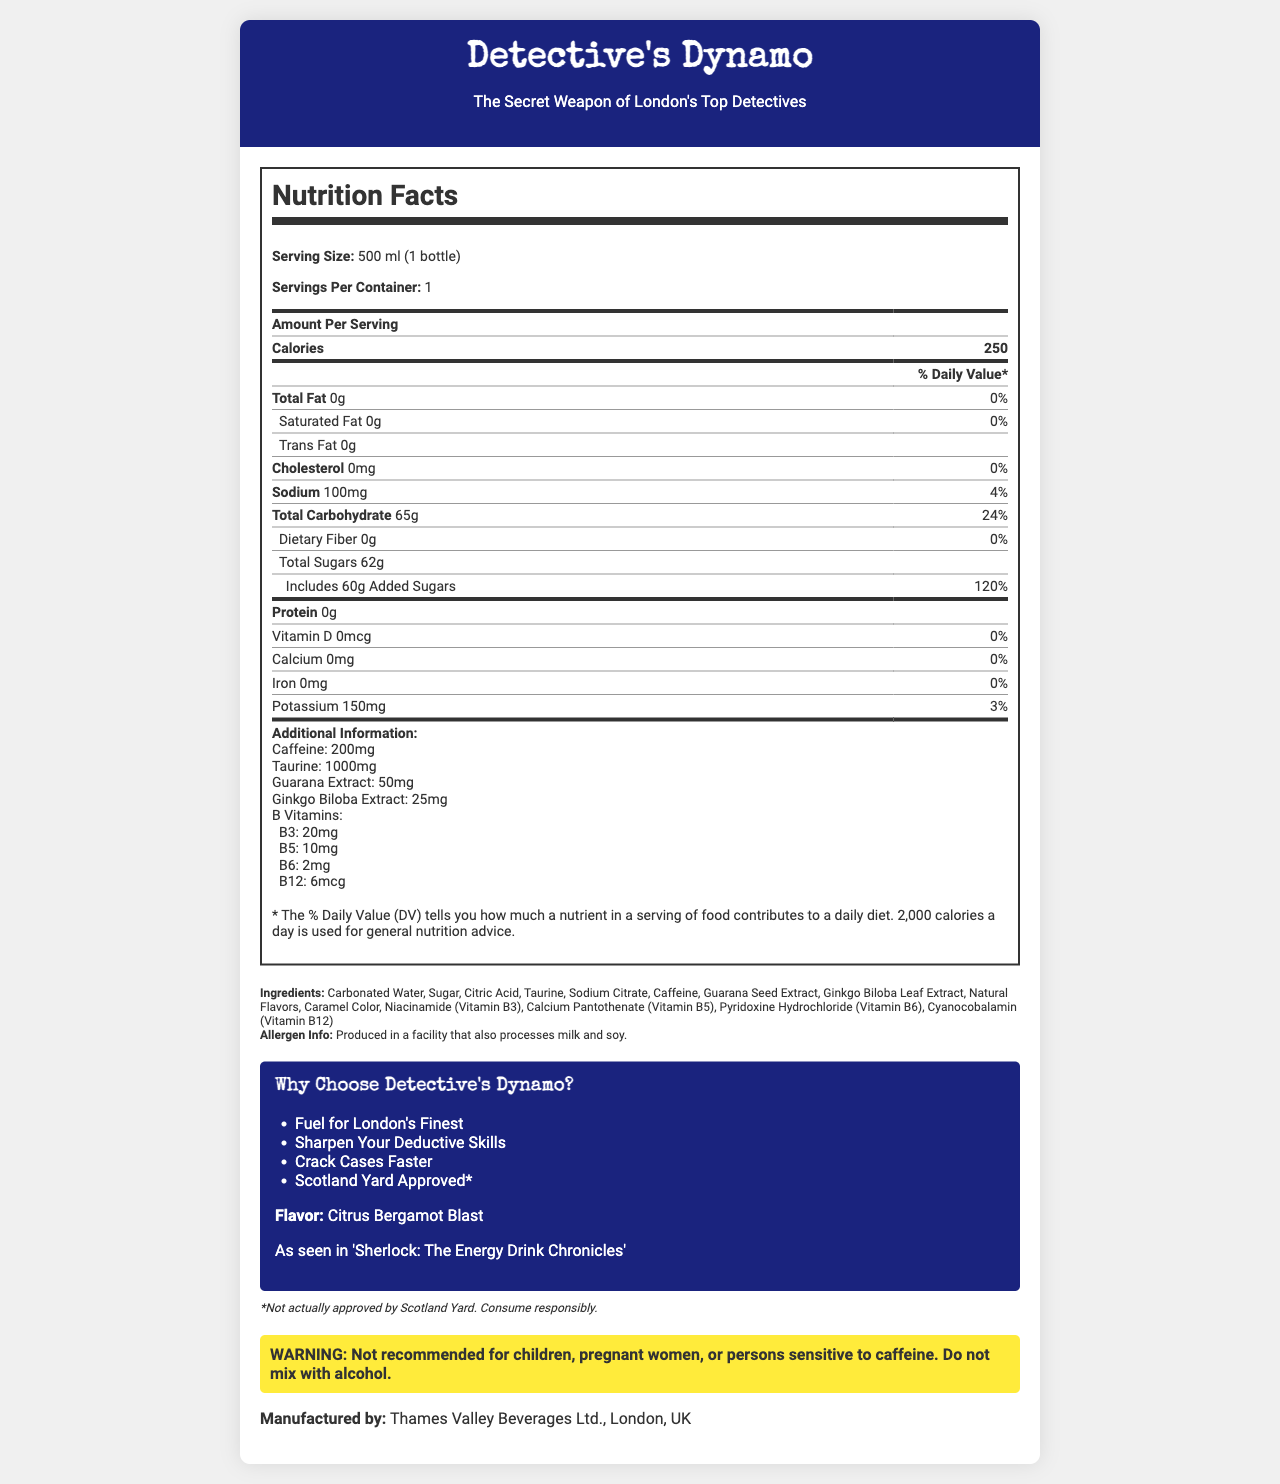what is the serving size of Detective's Dynamo? The serving size is clearly stated at the start of the Nutrition Facts section: "Serving Size: 500 ml (1 bottle)".
Answer: 500 ml (1 bottle) how many calories are in one serving? The number of calories is listed under the Nutrition Facts section as "Calories 250".
Answer: 250 what is the amount of added sugars in the drink? The amount of added sugars is provided in the Total Carbohydrate section under "Includes 60g Added Sugars".
Answer: 60g how many milligrams of sodium does the drink contain? The sodium content is listed in the nutrition information as "Sodium 100mg".
Answer: 100mg name one ingredient in Detective's Dynamo that is a natural flavor? Caramel Color is mentioned in the list of ingredients.
Answer: Caramel Color how many different B vitamins are included? The drink contains B3, B5, B6, and B12 vitamins, as listed under Additional Information.
Answer: 4 which of the following is NOT a marketing claim made by the drink? A. Boost your brain power B. Scotland Yard Approved* C. Crack Cases Faster "Boost your brain power" is not one of the listed marketing claims.
Answer: A what is the serving size of the drink? A. 250 ml (1 bottle) B. 500 ml (1 bottle) C. 750 ml (1 bottle) The serving size is clearly listed as "500 ml (1 bottle)".
Answer: B does the drink contain any protein? The Nutrition Facts section lists the protein content as "0g".
Answer: No summarize the main idea of the document The document targets readers by presenting detailed nutritional information, selling points, and a connection to London's detectives. It markets the drink as a superior energy source, citing its caffeine, taurine, and various B vitamins.
Answer: The document provides detailed nutrition facts, ingredient information, and marketing claims for a high-energy drink called "Detective's Dynamo". It highlights the product's energy-boosting properties, attributes its benefits to key ingredients like caffeine, taurine, and B vitamins, and connects it with a detective theme. is the product actually approved by Scotland Yard? The disclaimer at the bottom of the marketing section states "*Not actually approved by Scotland Yard".
Answer: No how much potassium is in the drink? The potassium content is listed in the nutrition information as "Potassium 150mg".
Answer: 150mg is the drink suitable for children? The warning section states that the drink is "Not recommended for children".
Answer: No does the product contain any dietary fiber? The Nutrition Facts section lists dietary fiber as "0g".
Answer: No can I mix this drink with alcohol according to the document? The warning section explicitly states, "Do not mix with alcohol".
Answer: No how much caffeine is in the drink? The amount of caffeine is listed under Additional Information as "Caffeine: 200mg".
Answer: 200mg who manufactures Detective's Dynamo? The manufacturer information is stated at the end of the document: "Manufactured by: Thames Valley Beverages Ltd., London, UK".
Answer: Thames Valley Beverages Ltd., London, UK how many marketing claims are mentioned in the document? There are four marketing claims listed: "Fuel for London's Finest", "Sharpen Your Deductive Skills", "Crack Cases Faster", and "Scotland Yard Approved*".
Answer: 4 what is the flavor profile of Detective's Dynamo? The flavor profile is mentioned under the marketing section as "Flavor: Citrus Bergamot Blast".
Answer: Citrus Bergamot Blast does the drink contain any cholesterol? The Nutrition Facts section lists cholesterol content as "0mg".
Answer: No how much Vitamin D is in the drink? The Vitamin D content is listed as "Vitamin D: 0mcg" in the nutrition information.
Answer: 0mcg how many servings are in one container? The Nutrition Facts section states "Servings Per Container: 1".
Answer: 1 which of the following fictional characters is associated with Detective's Dynamo? A. Sherlock Holmes B. Hercule Poirot C. Miss Marple The fictional endorsement mentions "Sherlock: The Energy Drink Chronicles".
Answer: A does the document provide information about how the drink affects blood pressure? There is no information in the document about the effects of the drink on blood pressure.
Answer: Not enough information 